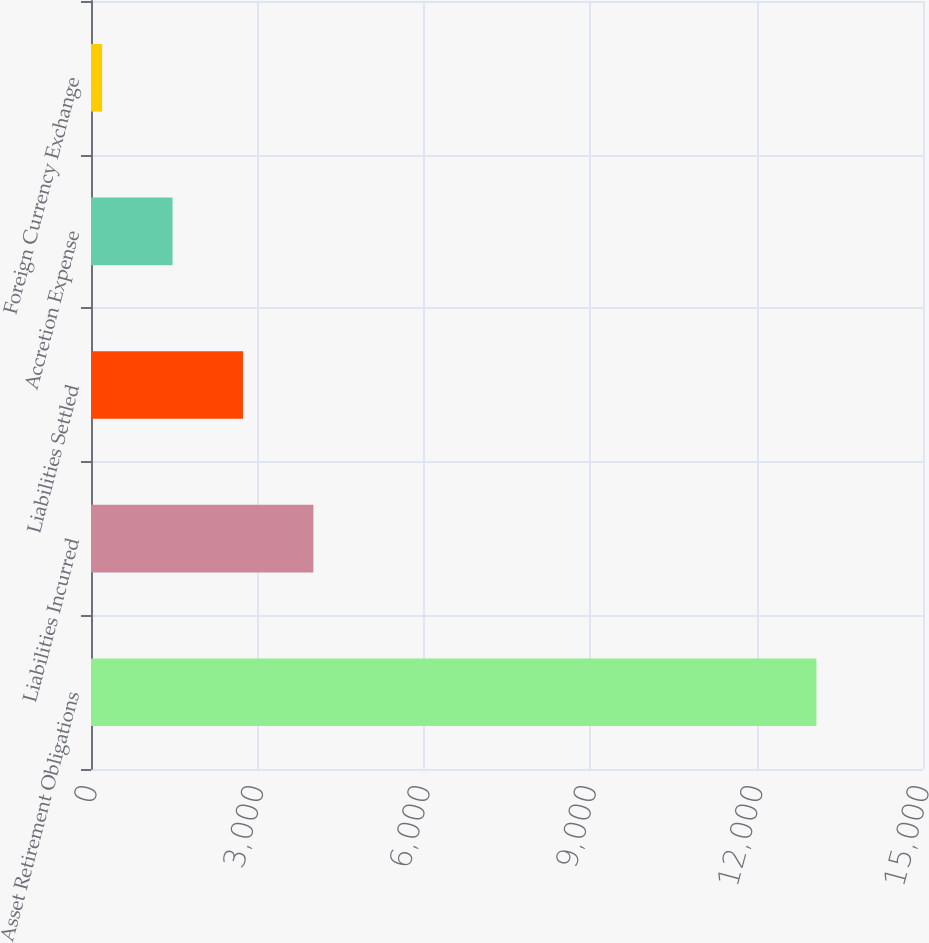Convert chart. <chart><loc_0><loc_0><loc_500><loc_500><bar_chart><fcel>Asset Retirement Obligations<fcel>Liabilities Incurred<fcel>Liabilities Settled<fcel>Accretion Expense<fcel>Foreign Currency Exchange<nl><fcel>13078.7<fcel>4009.1<fcel>2739.4<fcel>1469.7<fcel>200<nl></chart> 